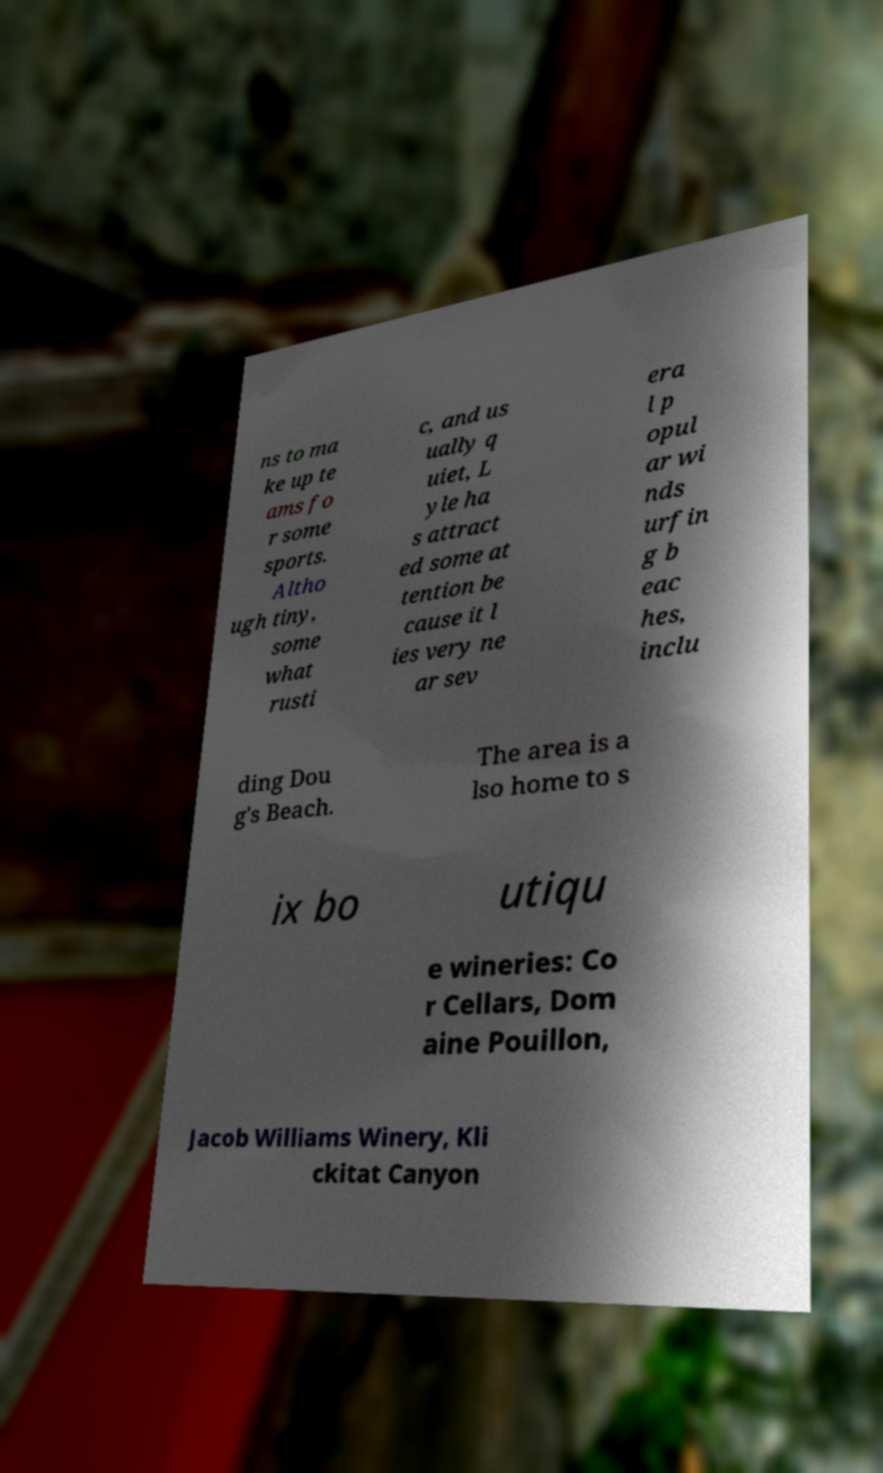Can you read and provide the text displayed in the image?This photo seems to have some interesting text. Can you extract and type it out for me? ns to ma ke up te ams fo r some sports. Altho ugh tiny, some what rusti c, and us ually q uiet, L yle ha s attract ed some at tention be cause it l ies very ne ar sev era l p opul ar wi nds urfin g b eac hes, inclu ding Dou g's Beach. The area is a lso home to s ix bo utiqu e wineries: Co r Cellars, Dom aine Pouillon, Jacob Williams Winery, Kli ckitat Canyon 